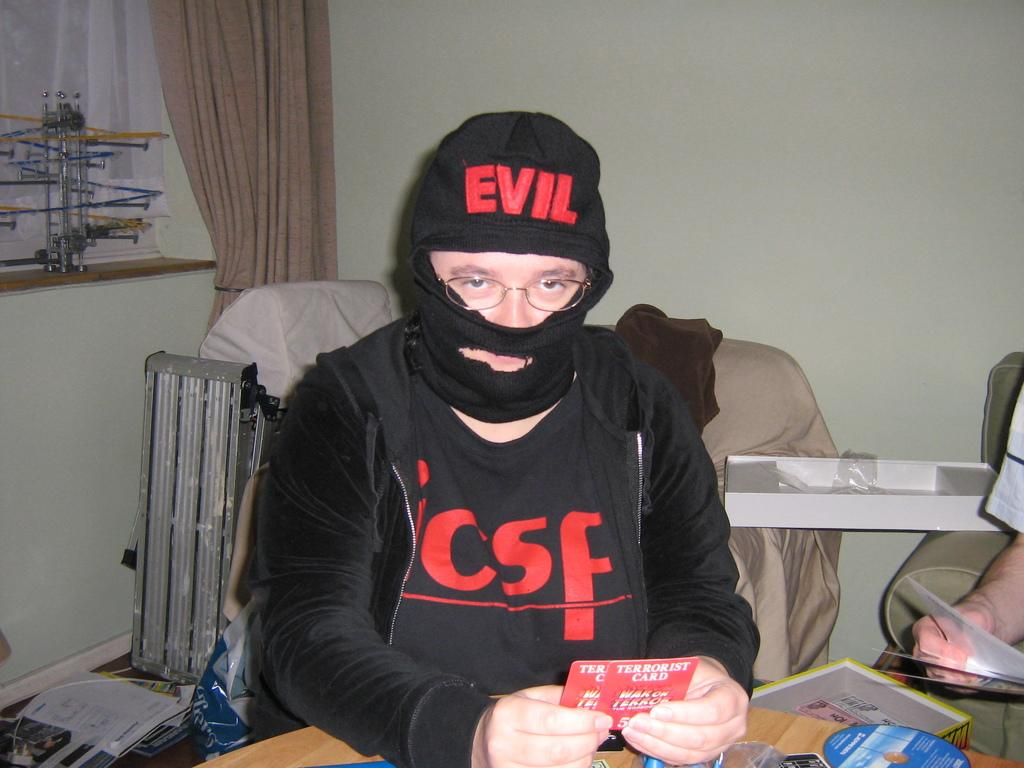Who or what is the main subject in the middle of the image? There is a person in the middle of the image. What is in front of the person? There is a table in front of the person. What object can be seen at the bottom of the image? There is a CD at the bottom of the image. Whose hand is visible on the right side of the image? There is another person's hand on the right side of the image. What type of camera is the person using to take a picture in the image? There is no camera visible in the image, so it cannot be determined if the person is using one. 